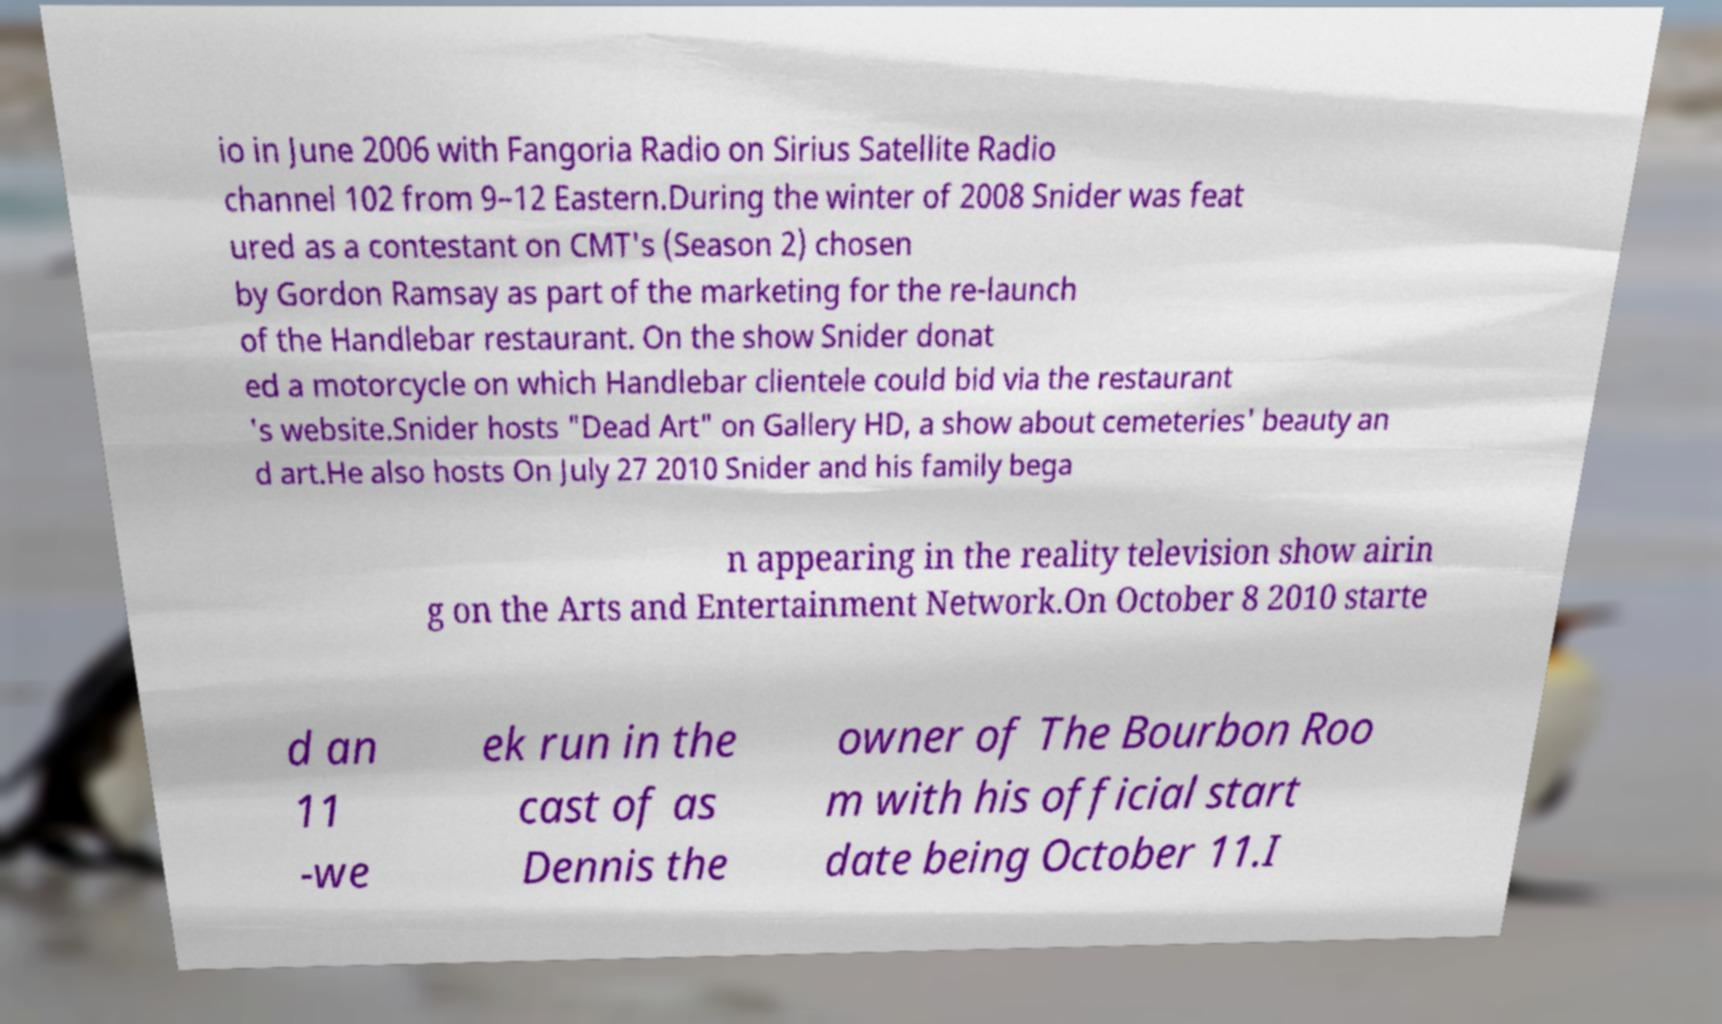Can you accurately transcribe the text from the provided image for me? io in June 2006 with Fangoria Radio on Sirius Satellite Radio channel 102 from 9–12 Eastern.During the winter of 2008 Snider was feat ured as a contestant on CMT's (Season 2) chosen by Gordon Ramsay as part of the marketing for the re-launch of the Handlebar restaurant. On the show Snider donat ed a motorcycle on which Handlebar clientele could bid via the restaurant 's website.Snider hosts "Dead Art" on Gallery HD, a show about cemeteries' beauty an d art.He also hosts On July 27 2010 Snider and his family bega n appearing in the reality television show airin g on the Arts and Entertainment Network.On October 8 2010 starte d an 11 -we ek run in the cast of as Dennis the owner of The Bourbon Roo m with his official start date being October 11.I 